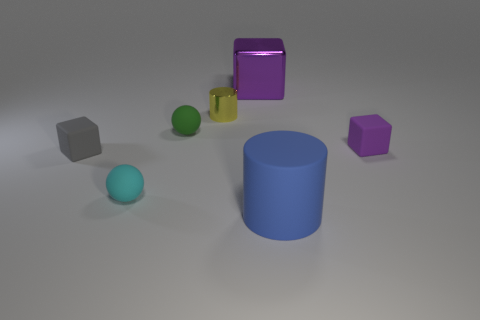Are there any small gray cubes that have the same material as the small cyan sphere?
Give a very brief answer. Yes. What material is the small gray object?
Your response must be concise. Rubber. The purple thing behind the cylinder behind the tiny matte cube on the right side of the small yellow metallic object is what shape?
Provide a short and direct response. Cube. Is the number of big objects that are in front of the tiny cyan sphere greater than the number of tiny red objects?
Give a very brief answer. Yes. There is a small cyan object; is it the same shape as the small rubber object right of the small green object?
Offer a very short reply. No. There is another thing that is the same color as the big metallic object; what is its shape?
Your response must be concise. Cube. How many yellow things are behind the tiny matte cube that is to the left of the thing right of the blue rubber thing?
Provide a short and direct response. 1. The shiny cube that is the same size as the blue cylinder is what color?
Your answer should be compact. Purple. There is a purple cube to the left of the cylinder that is right of the metallic cylinder; what size is it?
Provide a succinct answer. Large. What number of other objects are the same size as the cyan ball?
Give a very brief answer. 4. 